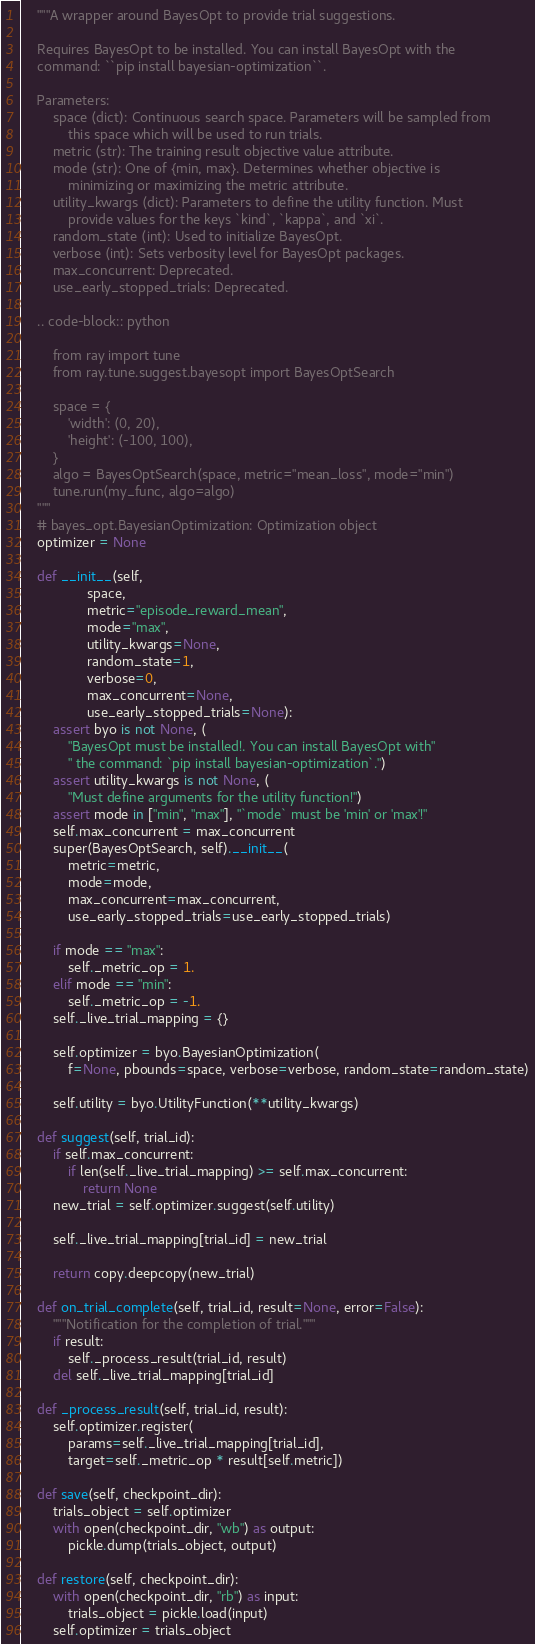<code> <loc_0><loc_0><loc_500><loc_500><_Python_>    """A wrapper around BayesOpt to provide trial suggestions.

    Requires BayesOpt to be installed. You can install BayesOpt with the
    command: ``pip install bayesian-optimization``.

    Parameters:
        space (dict): Continuous search space. Parameters will be sampled from
            this space which will be used to run trials.
        metric (str): The training result objective value attribute.
        mode (str): One of {min, max}. Determines whether objective is
            minimizing or maximizing the metric attribute.
        utility_kwargs (dict): Parameters to define the utility function. Must
            provide values for the keys `kind`, `kappa`, and `xi`.
        random_state (int): Used to initialize BayesOpt.
        verbose (int): Sets verbosity level for BayesOpt packages.
        max_concurrent: Deprecated.
        use_early_stopped_trials: Deprecated.

    .. code-block:: python

        from ray import tune
        from ray.tune.suggest.bayesopt import BayesOptSearch

        space = {
            'width': (0, 20),
            'height': (-100, 100),
        }
        algo = BayesOptSearch(space, metric="mean_loss", mode="min")
        tune.run(my_func, algo=algo)
    """
    # bayes_opt.BayesianOptimization: Optimization object
    optimizer = None

    def __init__(self,
                 space,
                 metric="episode_reward_mean",
                 mode="max",
                 utility_kwargs=None,
                 random_state=1,
                 verbose=0,
                 max_concurrent=None,
                 use_early_stopped_trials=None):
        assert byo is not None, (
            "BayesOpt must be installed!. You can install BayesOpt with"
            " the command: `pip install bayesian-optimization`.")
        assert utility_kwargs is not None, (
            "Must define arguments for the utility function!")
        assert mode in ["min", "max"], "`mode` must be 'min' or 'max'!"
        self.max_concurrent = max_concurrent
        super(BayesOptSearch, self).__init__(
            metric=metric,
            mode=mode,
            max_concurrent=max_concurrent,
            use_early_stopped_trials=use_early_stopped_trials)

        if mode == "max":
            self._metric_op = 1.
        elif mode == "min":
            self._metric_op = -1.
        self._live_trial_mapping = {}

        self.optimizer = byo.BayesianOptimization(
            f=None, pbounds=space, verbose=verbose, random_state=random_state)

        self.utility = byo.UtilityFunction(**utility_kwargs)

    def suggest(self, trial_id):
        if self.max_concurrent:
            if len(self._live_trial_mapping) >= self.max_concurrent:
                return None
        new_trial = self.optimizer.suggest(self.utility)

        self._live_trial_mapping[trial_id] = new_trial

        return copy.deepcopy(new_trial)

    def on_trial_complete(self, trial_id, result=None, error=False):
        """Notification for the completion of trial."""
        if result:
            self._process_result(trial_id, result)
        del self._live_trial_mapping[trial_id]

    def _process_result(self, trial_id, result):
        self.optimizer.register(
            params=self._live_trial_mapping[trial_id],
            target=self._metric_op * result[self.metric])

    def save(self, checkpoint_dir):
        trials_object = self.optimizer
        with open(checkpoint_dir, "wb") as output:
            pickle.dump(trials_object, output)

    def restore(self, checkpoint_dir):
        with open(checkpoint_dir, "rb") as input:
            trials_object = pickle.load(input)
        self.optimizer = trials_object
</code> 